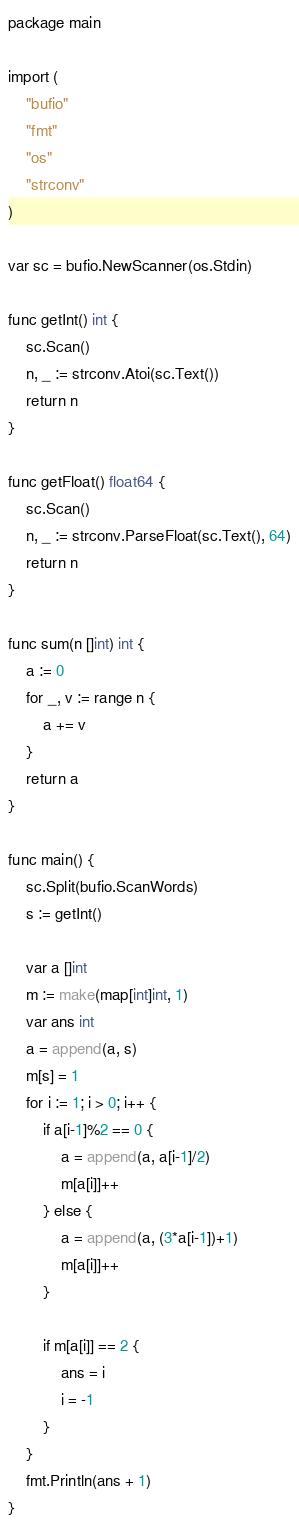Convert code to text. <code><loc_0><loc_0><loc_500><loc_500><_Go_>package main

import (
	"bufio"
	"fmt"
	"os"
	"strconv"
)

var sc = bufio.NewScanner(os.Stdin)

func getInt() int {
	sc.Scan()
	n, _ := strconv.Atoi(sc.Text())
	return n
}

func getFloat() float64 {
	sc.Scan()
	n, _ := strconv.ParseFloat(sc.Text(), 64)
	return n
}

func sum(n []int) int {
	a := 0
	for _, v := range n {
		a += v
	}
	return a
}

func main() {
	sc.Split(bufio.ScanWords)
	s := getInt()

	var a []int
	m := make(map[int]int, 1)
	var ans int
	a = append(a, s)
	m[s] = 1
	for i := 1; i > 0; i++ {
		if a[i-1]%2 == 0 {
			a = append(a, a[i-1]/2)
			m[a[i]]++
		} else {
			a = append(a, (3*a[i-1])+1)
			m[a[i]]++
		}

		if m[a[i]] == 2 {
			ans = i
			i = -1
		}
	}
	fmt.Println(ans + 1)
}
</code> 